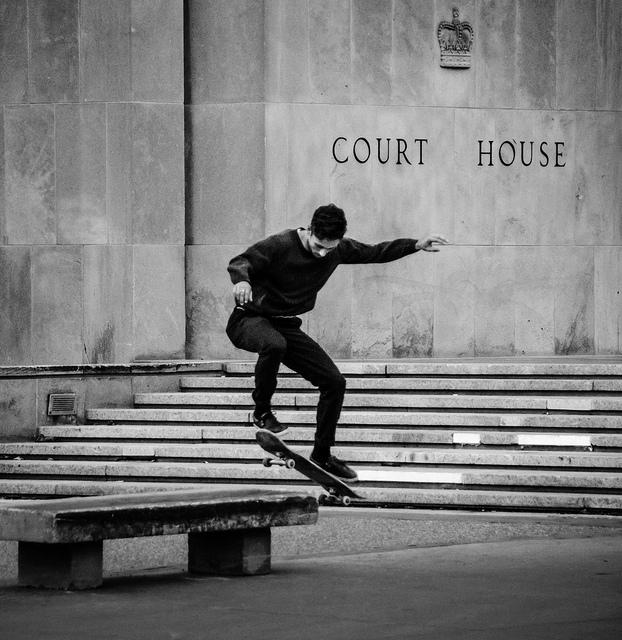In what type setting does the skateboarder skate here? Please explain your reasoning. urban. The setting is urban. 